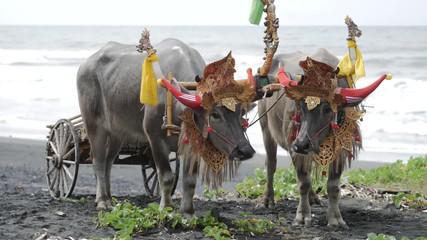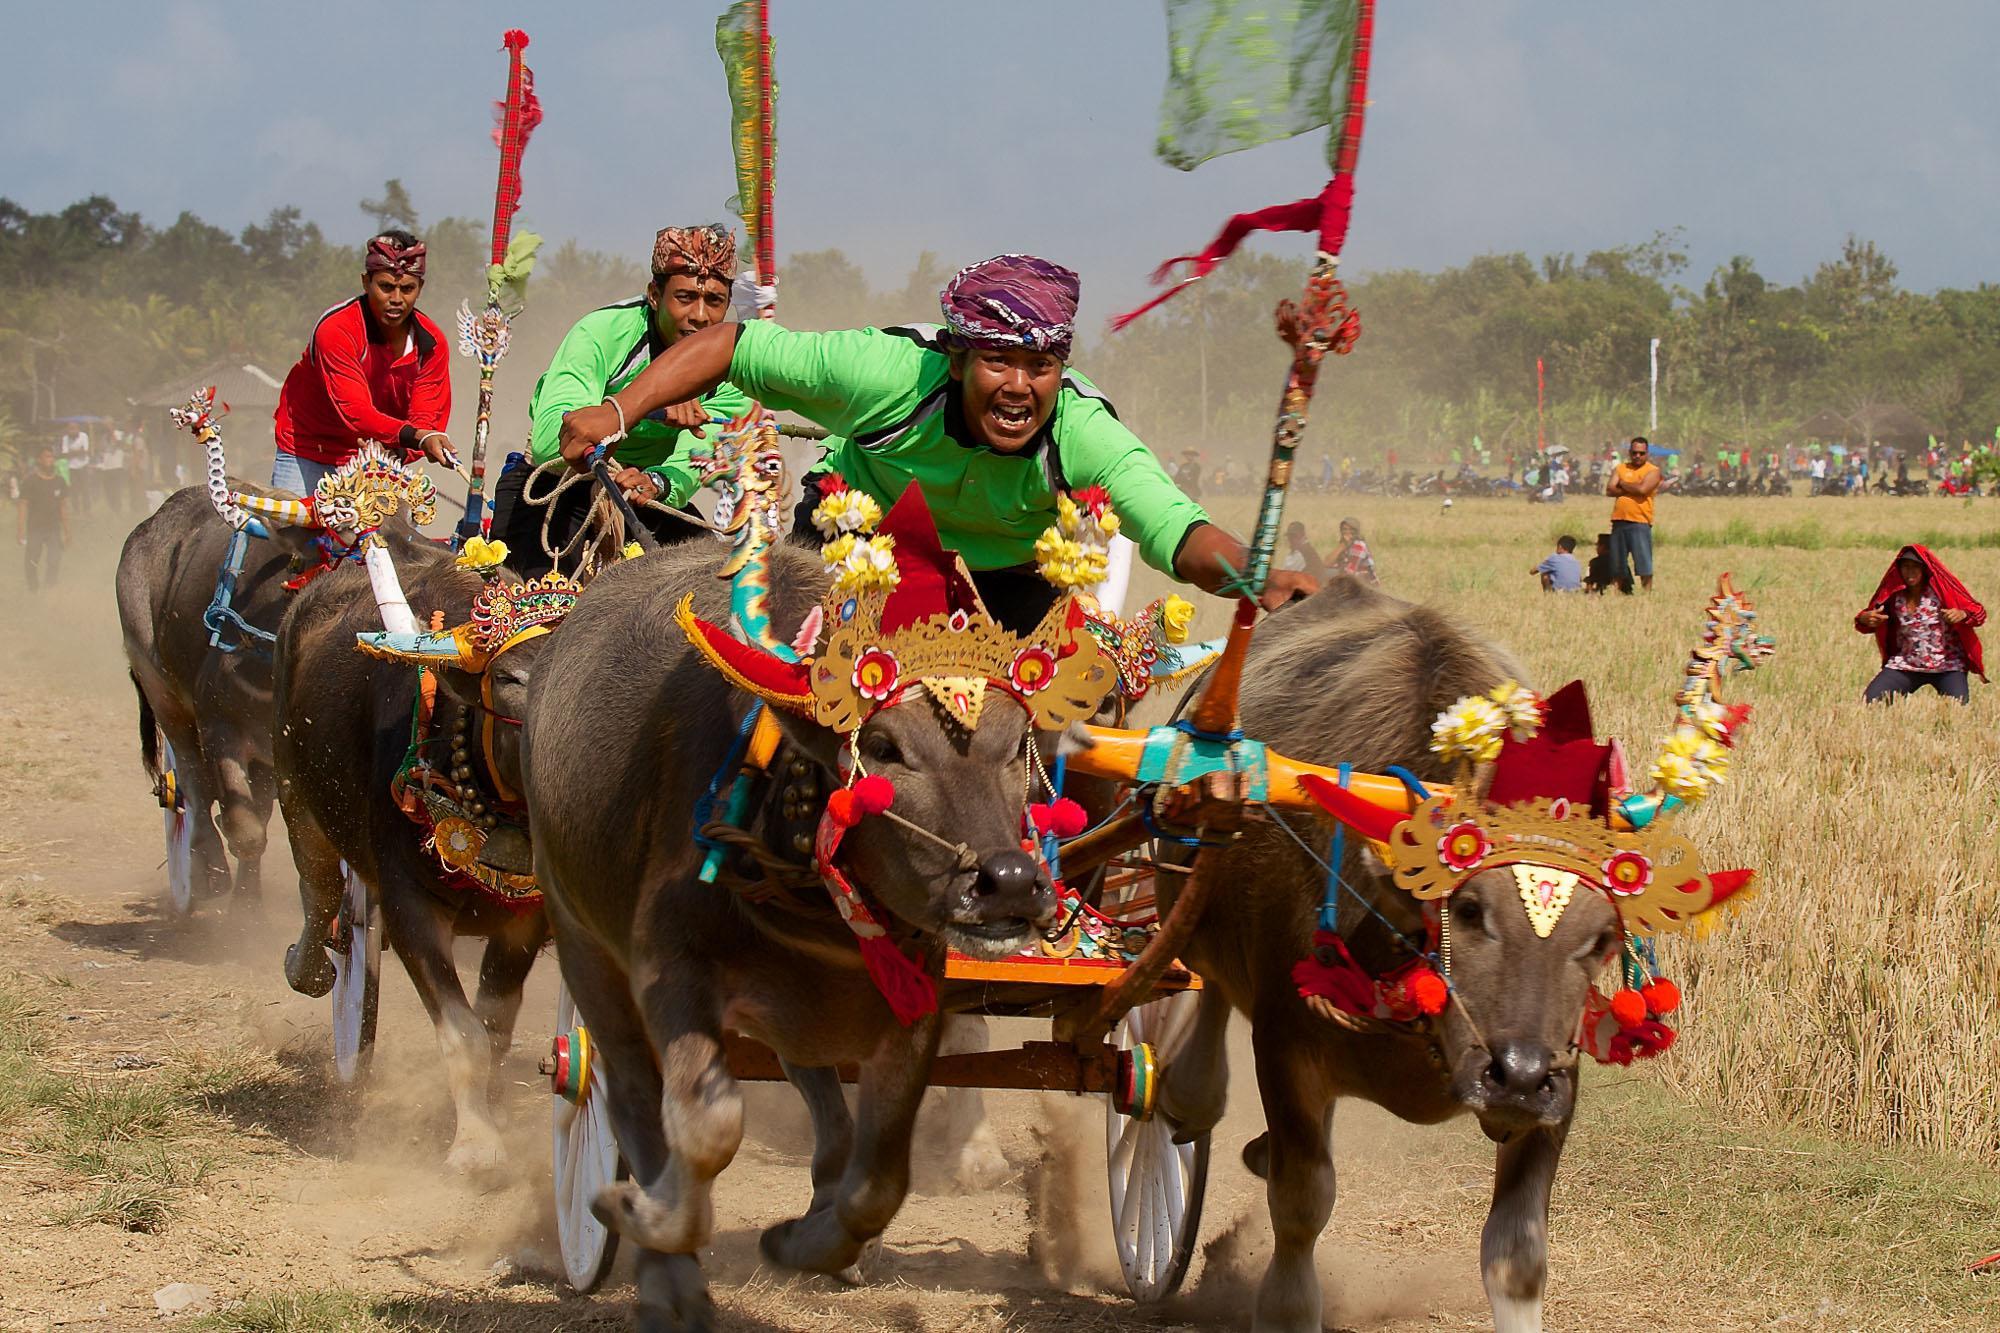The first image is the image on the left, the second image is the image on the right. Analyze the images presented: Is the assertion "in at least one image there are two black bull in red headdress running right attached to a chaireate." valid? Answer yes or no. No. The first image is the image on the left, the second image is the image on the right. Evaluate the accuracy of this statement regarding the images: "In the right image, two ox-cart racers in green shirts are driving teams of two non-black oxen to the right.". Is it true? Answer yes or no. Yes. 